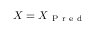Convert formula to latex. <formula><loc_0><loc_0><loc_500><loc_500>X = X _ { P r e d }</formula> 